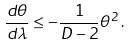Convert formula to latex. <formula><loc_0><loc_0><loc_500><loc_500>\frac { d \theta } { d \lambda } \leq - \frac { 1 } { D - 2 } \theta ^ { 2 } \, .</formula> 